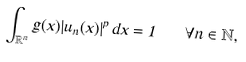<formula> <loc_0><loc_0><loc_500><loc_500>\int _ { \mathbb { R } ^ { n } } g ( x ) | u _ { n } ( x ) | ^ { p } \, d x = 1 \quad \forall n \in \mathbb { N } ,</formula> 